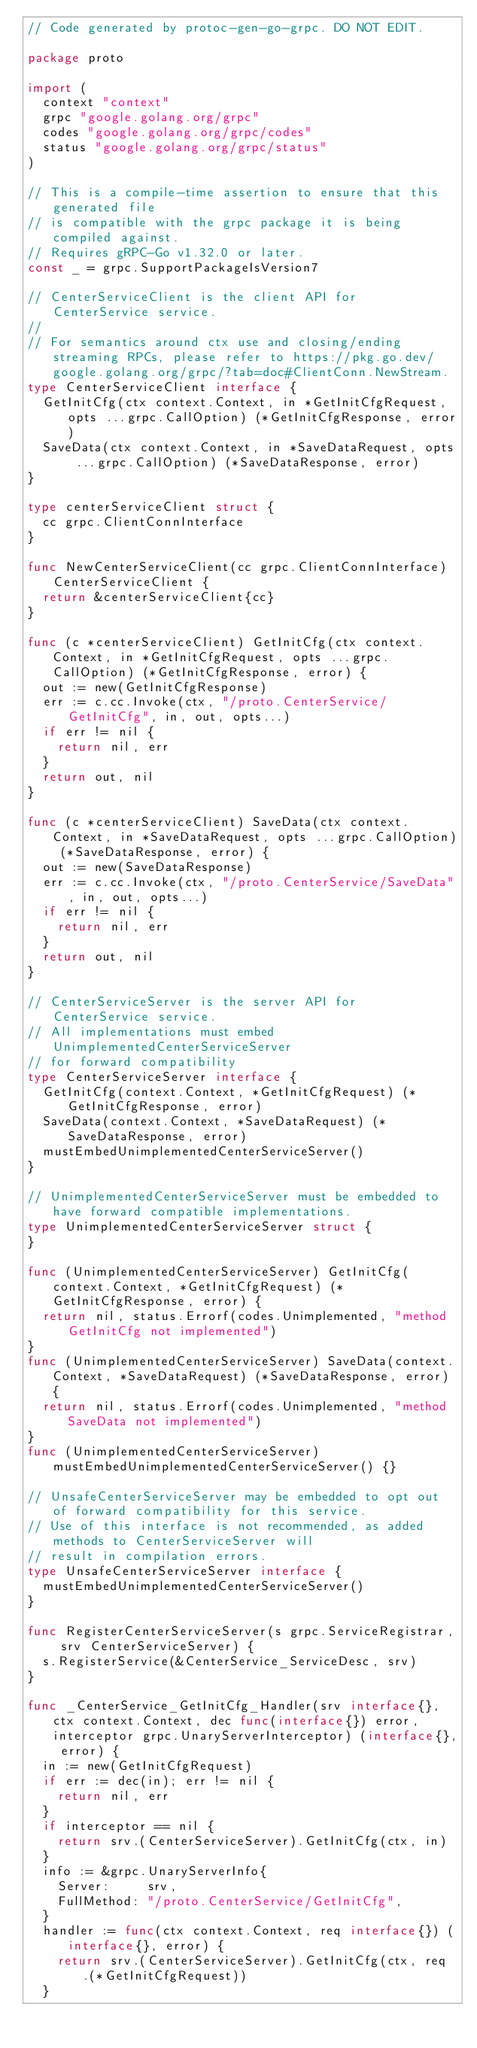Convert code to text. <code><loc_0><loc_0><loc_500><loc_500><_Go_>// Code generated by protoc-gen-go-grpc. DO NOT EDIT.

package proto

import (
	context "context"
	grpc "google.golang.org/grpc"
	codes "google.golang.org/grpc/codes"
	status "google.golang.org/grpc/status"
)

// This is a compile-time assertion to ensure that this generated file
// is compatible with the grpc package it is being compiled against.
// Requires gRPC-Go v1.32.0 or later.
const _ = grpc.SupportPackageIsVersion7

// CenterServiceClient is the client API for CenterService service.
//
// For semantics around ctx use and closing/ending streaming RPCs, please refer to https://pkg.go.dev/google.golang.org/grpc/?tab=doc#ClientConn.NewStream.
type CenterServiceClient interface {
	GetInitCfg(ctx context.Context, in *GetInitCfgRequest, opts ...grpc.CallOption) (*GetInitCfgResponse, error)
	SaveData(ctx context.Context, in *SaveDataRequest, opts ...grpc.CallOption) (*SaveDataResponse, error)
}

type centerServiceClient struct {
	cc grpc.ClientConnInterface
}

func NewCenterServiceClient(cc grpc.ClientConnInterface) CenterServiceClient {
	return &centerServiceClient{cc}
}

func (c *centerServiceClient) GetInitCfg(ctx context.Context, in *GetInitCfgRequest, opts ...grpc.CallOption) (*GetInitCfgResponse, error) {
	out := new(GetInitCfgResponse)
	err := c.cc.Invoke(ctx, "/proto.CenterService/GetInitCfg", in, out, opts...)
	if err != nil {
		return nil, err
	}
	return out, nil
}

func (c *centerServiceClient) SaveData(ctx context.Context, in *SaveDataRequest, opts ...grpc.CallOption) (*SaveDataResponse, error) {
	out := new(SaveDataResponse)
	err := c.cc.Invoke(ctx, "/proto.CenterService/SaveData", in, out, opts...)
	if err != nil {
		return nil, err
	}
	return out, nil
}

// CenterServiceServer is the server API for CenterService service.
// All implementations must embed UnimplementedCenterServiceServer
// for forward compatibility
type CenterServiceServer interface {
	GetInitCfg(context.Context, *GetInitCfgRequest) (*GetInitCfgResponse, error)
	SaveData(context.Context, *SaveDataRequest) (*SaveDataResponse, error)
	mustEmbedUnimplementedCenterServiceServer()
}

// UnimplementedCenterServiceServer must be embedded to have forward compatible implementations.
type UnimplementedCenterServiceServer struct {
}

func (UnimplementedCenterServiceServer) GetInitCfg(context.Context, *GetInitCfgRequest) (*GetInitCfgResponse, error) {
	return nil, status.Errorf(codes.Unimplemented, "method GetInitCfg not implemented")
}
func (UnimplementedCenterServiceServer) SaveData(context.Context, *SaveDataRequest) (*SaveDataResponse, error) {
	return nil, status.Errorf(codes.Unimplemented, "method SaveData not implemented")
}
func (UnimplementedCenterServiceServer) mustEmbedUnimplementedCenterServiceServer() {}

// UnsafeCenterServiceServer may be embedded to opt out of forward compatibility for this service.
// Use of this interface is not recommended, as added methods to CenterServiceServer will
// result in compilation errors.
type UnsafeCenterServiceServer interface {
	mustEmbedUnimplementedCenterServiceServer()
}

func RegisterCenterServiceServer(s grpc.ServiceRegistrar, srv CenterServiceServer) {
	s.RegisterService(&CenterService_ServiceDesc, srv)
}

func _CenterService_GetInitCfg_Handler(srv interface{}, ctx context.Context, dec func(interface{}) error, interceptor grpc.UnaryServerInterceptor) (interface{}, error) {
	in := new(GetInitCfgRequest)
	if err := dec(in); err != nil {
		return nil, err
	}
	if interceptor == nil {
		return srv.(CenterServiceServer).GetInitCfg(ctx, in)
	}
	info := &grpc.UnaryServerInfo{
		Server:     srv,
		FullMethod: "/proto.CenterService/GetInitCfg",
	}
	handler := func(ctx context.Context, req interface{}) (interface{}, error) {
		return srv.(CenterServiceServer).GetInitCfg(ctx, req.(*GetInitCfgRequest))
	}</code> 